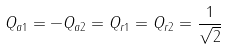Convert formula to latex. <formula><loc_0><loc_0><loc_500><loc_500>Q _ { a 1 } = - Q _ { a 2 } = Q _ { r 1 } = Q _ { r 2 } = \frac { 1 } { \sqrt { 2 } }</formula> 